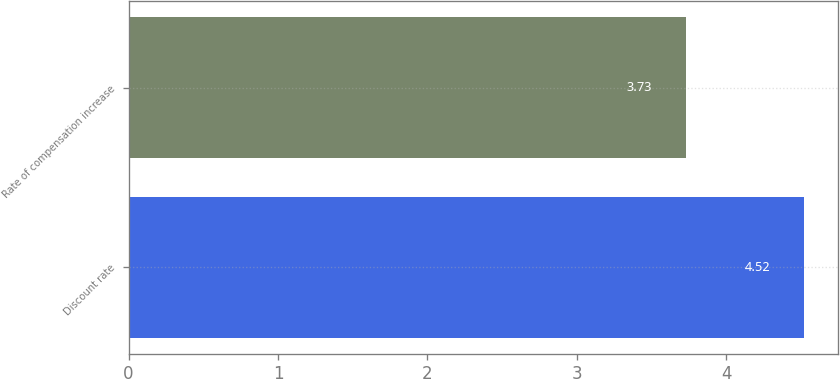Convert chart. <chart><loc_0><loc_0><loc_500><loc_500><bar_chart><fcel>Discount rate<fcel>Rate of compensation increase<nl><fcel>4.52<fcel>3.73<nl></chart> 